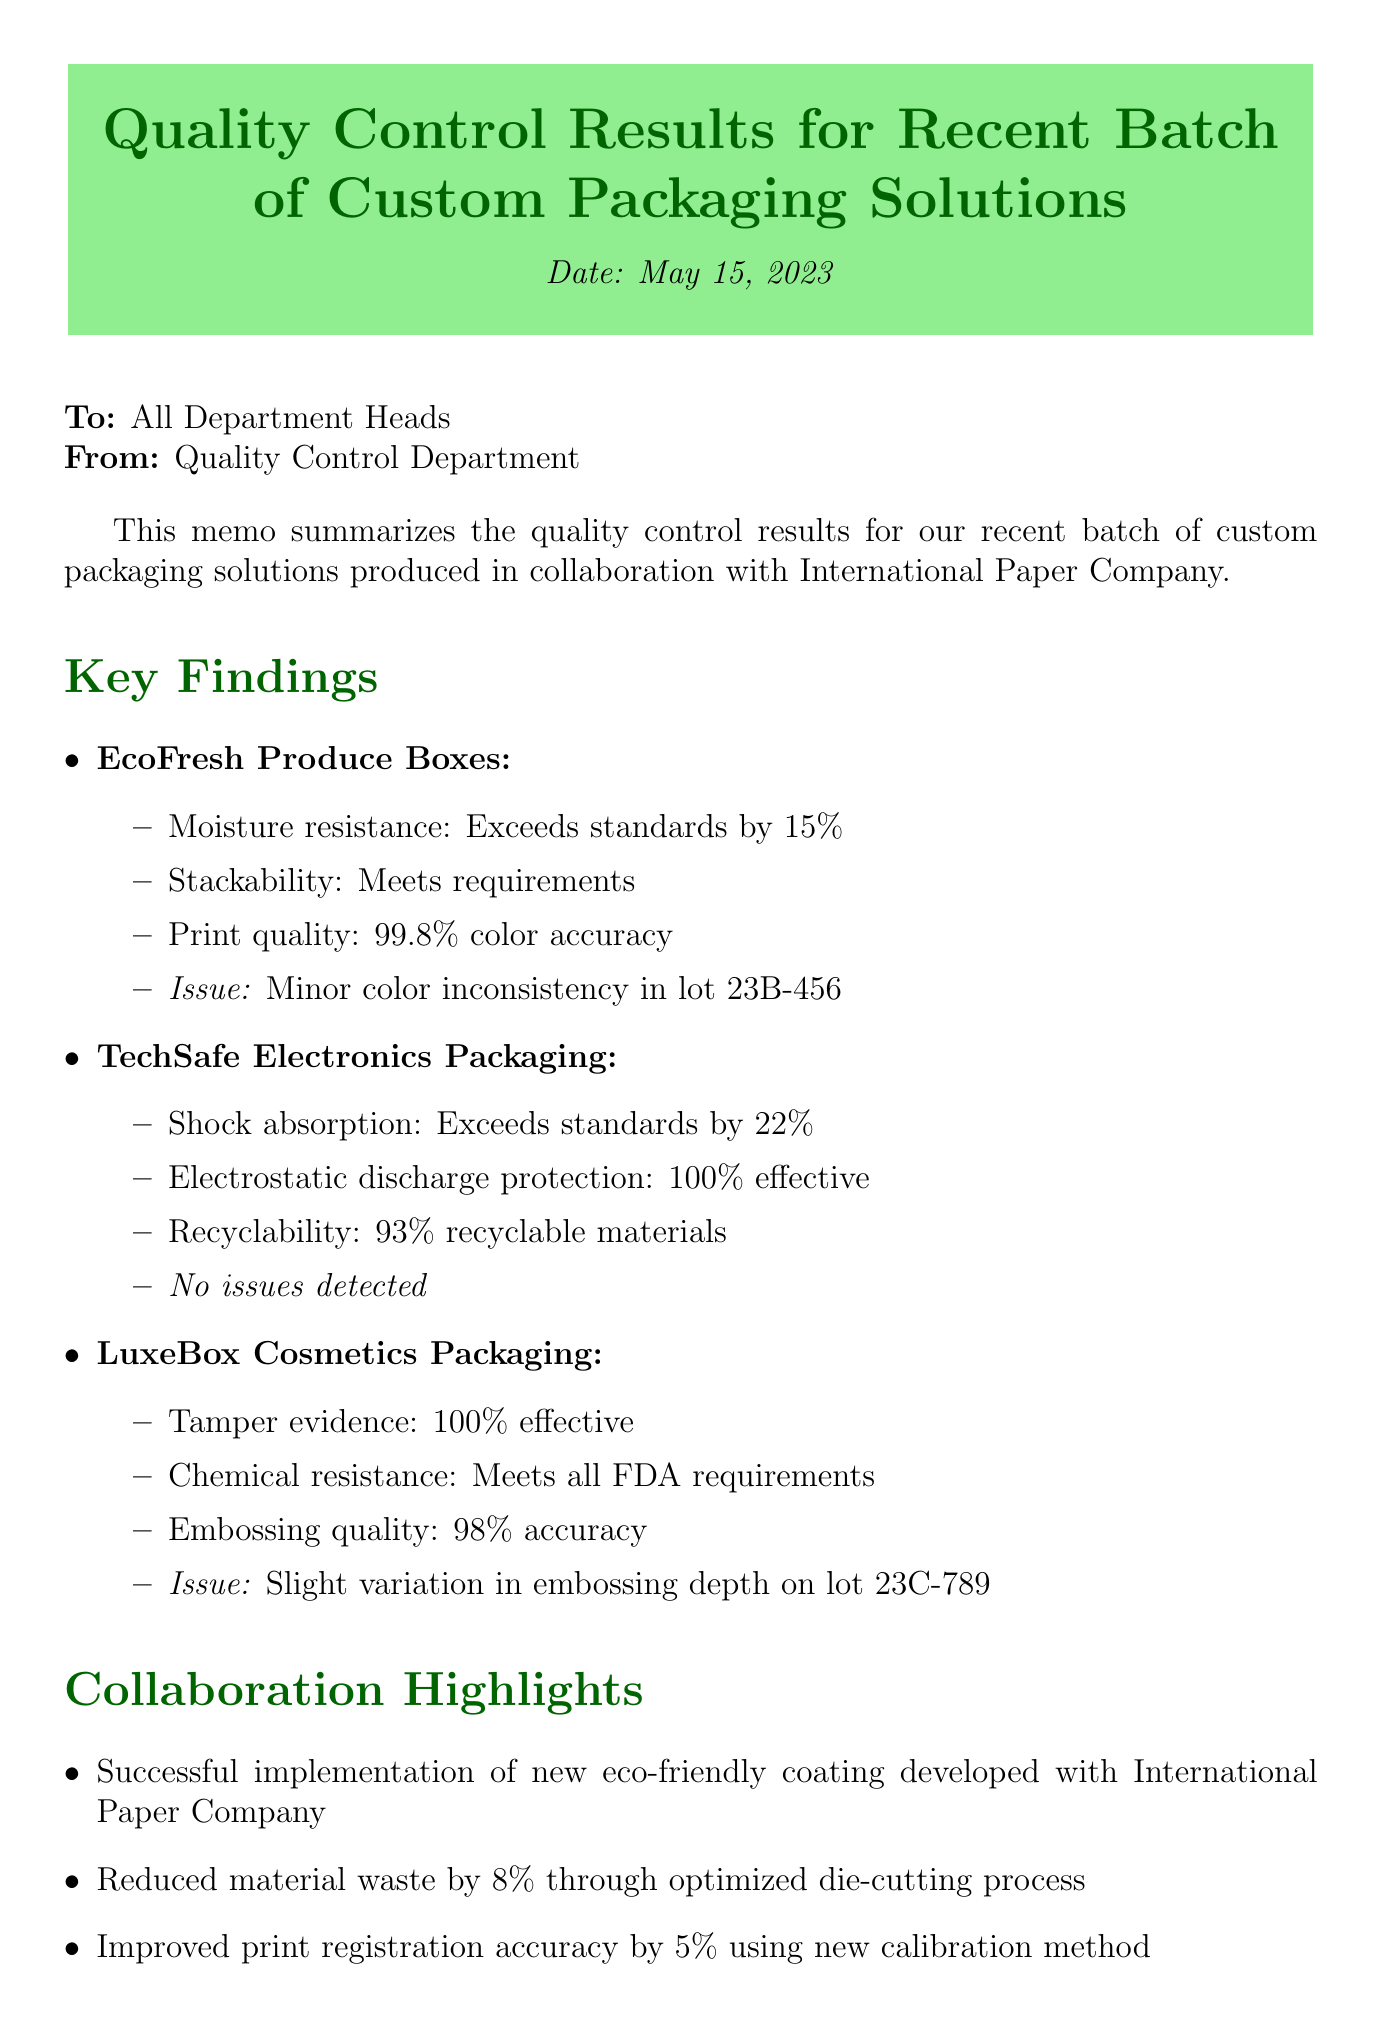What is the date of the memo? The date of the memo is explicitly mentioned at the beginning of the document as "2023-05-15".
Answer: 2023-05-15 Who is the recipient of the memo? The recipient is listed in the document as "All Department Heads".
Answer: All Department Heads What product line had minor color inconsistency in lot 23B-456? The document specifies that the "EcoFresh Produce Boxes" had minor color inconsistency in lot 23B-456.
Answer: EcoFresh Produce Boxes What percentage of recyclability does TechSafe Electronics Packaging have? The document states that "TechSafe Electronics Packaging" is "93% recyclable materials".
Answer: 93% recyclable materials What collaboration highlight mentions waste reduction? The document notes the collaboration highlight as "Reduced material waste by 8% through optimized die-cutting process".
Answer: Reduced material waste by 8% Which client provided feedback on LuxeBox Cosmetics Packaging? The document indicates that "GlamourGlow Cosmetics" provided feedback on "LuxeBox Cosmetics Packaging".
Answer: GlamourGlow Cosmetics What is one action item mentioned in the memo? The memo lists several action items, one of which is to "Schedule meeting with International Paper Company to discuss color consistency improvements".
Answer: Schedule meeting with International Paper Company What is the moisture resistance result for EcoFresh Produce Boxes? The document mentions that the moisture resistance for "EcoFresh Produce Boxes" "Exceeds standards by 15%".
Answer: Exceeds standards by 15% What was the print quality accuracy for EcoFresh Produce Boxes? According to the document, the print quality for "EcoFresh Produce Boxes" is "99.8% color accuracy".
Answer: 99.8% color accuracy 